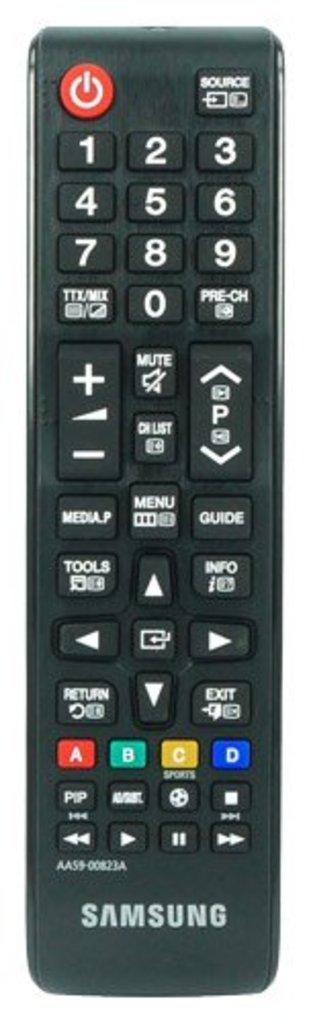<image>
Share a concise interpretation of the image provided. A black Samsung remote with colored buttons that say A, B, C, and D. 